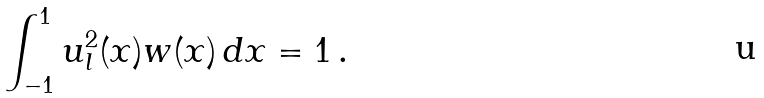<formula> <loc_0><loc_0><loc_500><loc_500>\int _ { - 1 } ^ { 1 } u _ { l } ^ { 2 } ( x ) w ( x ) \, d x = 1 \, .</formula> 